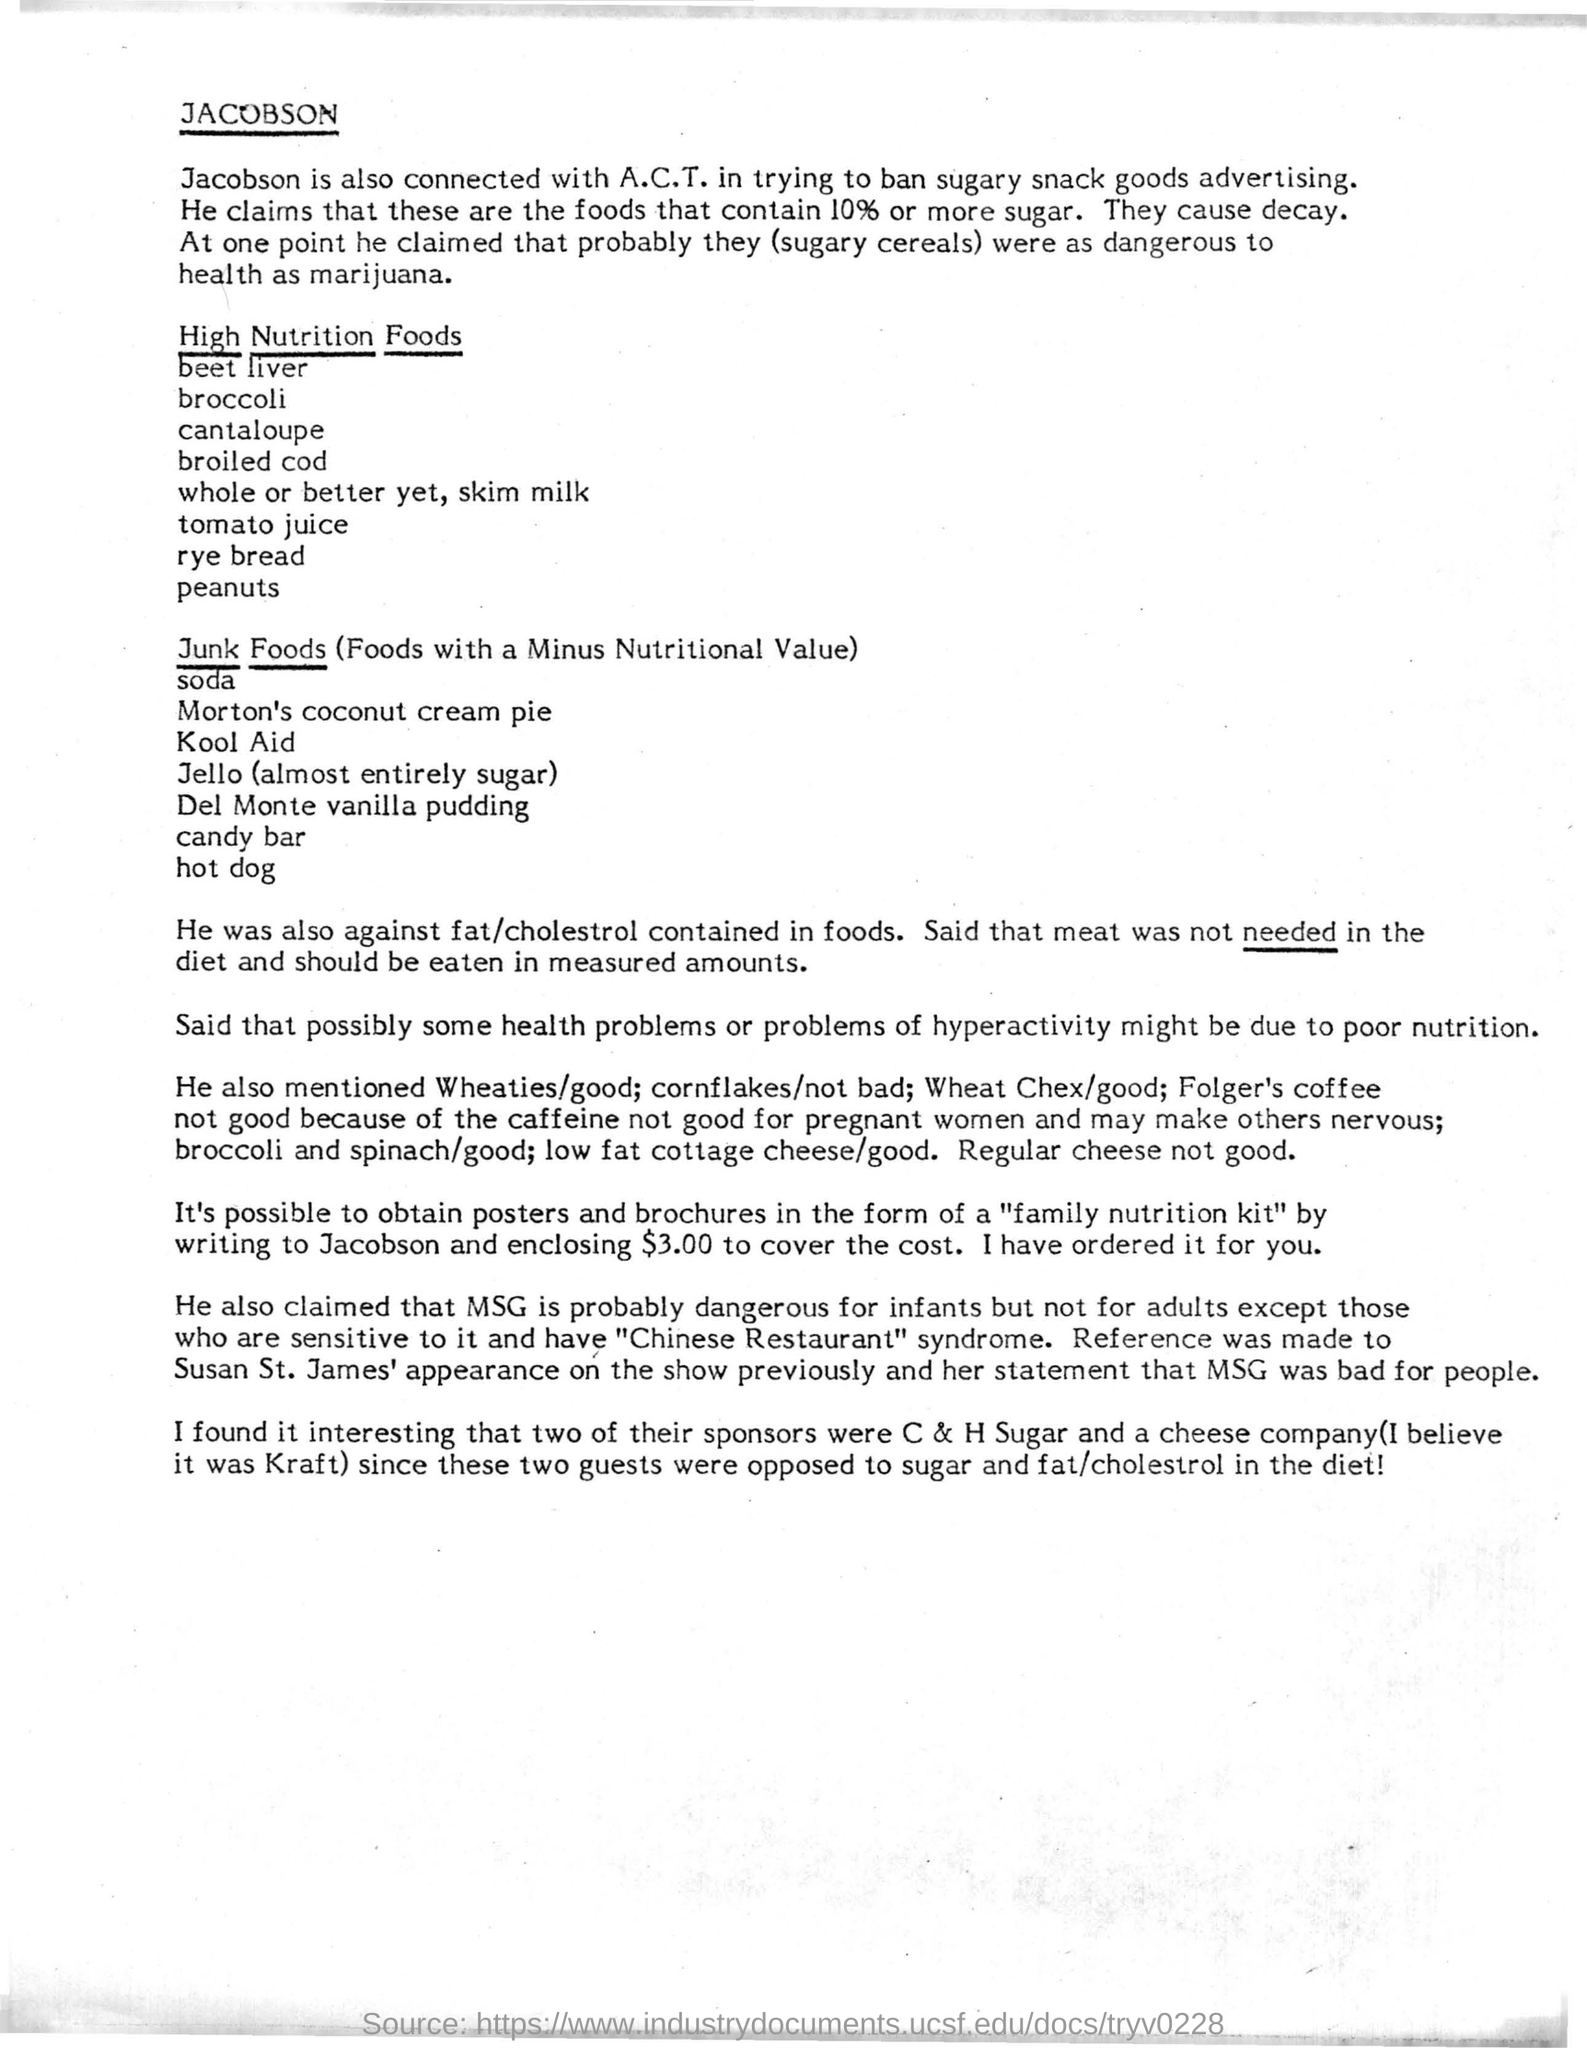Who is also connected with A.C.T in trying to ban sugary snack goods advertising?
Give a very brief answer. Jacobson. 